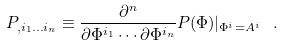<formula> <loc_0><loc_0><loc_500><loc_500>P _ { , i _ { 1 } \dots i _ { n } } \equiv \frac { \partial ^ { n } } { \partial \Phi ^ { i _ { 1 } } \cdots \partial \Phi ^ { i _ { n } } } P ( \Phi ) | _ { \Phi ^ { i } = A ^ { i } } \ .</formula> 